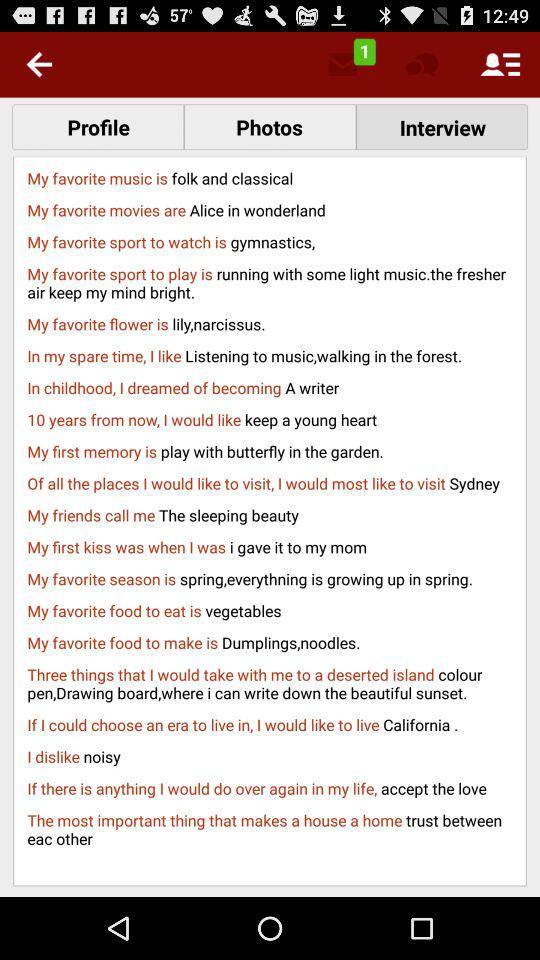What is my favorite music? Your favorite music is folk and classical. 